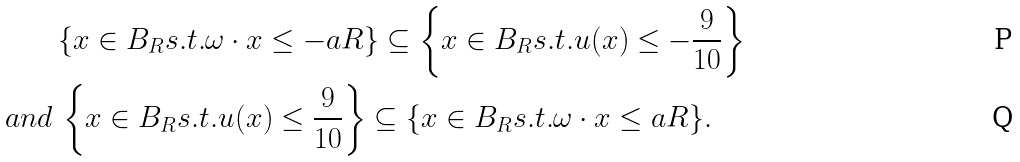Convert formula to latex. <formula><loc_0><loc_0><loc_500><loc_500>& \{ x \in B _ { R } { s . t . } \omega \cdot x \leq - a R \} \subseteq \left \{ x \in B _ { R } { s . t . } u ( x ) \leq - \frac { 9 } { 1 0 } \right \} \\ { a n d } \, & \left \{ x \in B _ { R } { s . t . } u ( x ) \leq \frac { 9 } { 1 0 } \right \} \subseteq \{ x \in B _ { R } { s . t . } \omega \cdot x \leq a R \} .</formula> 